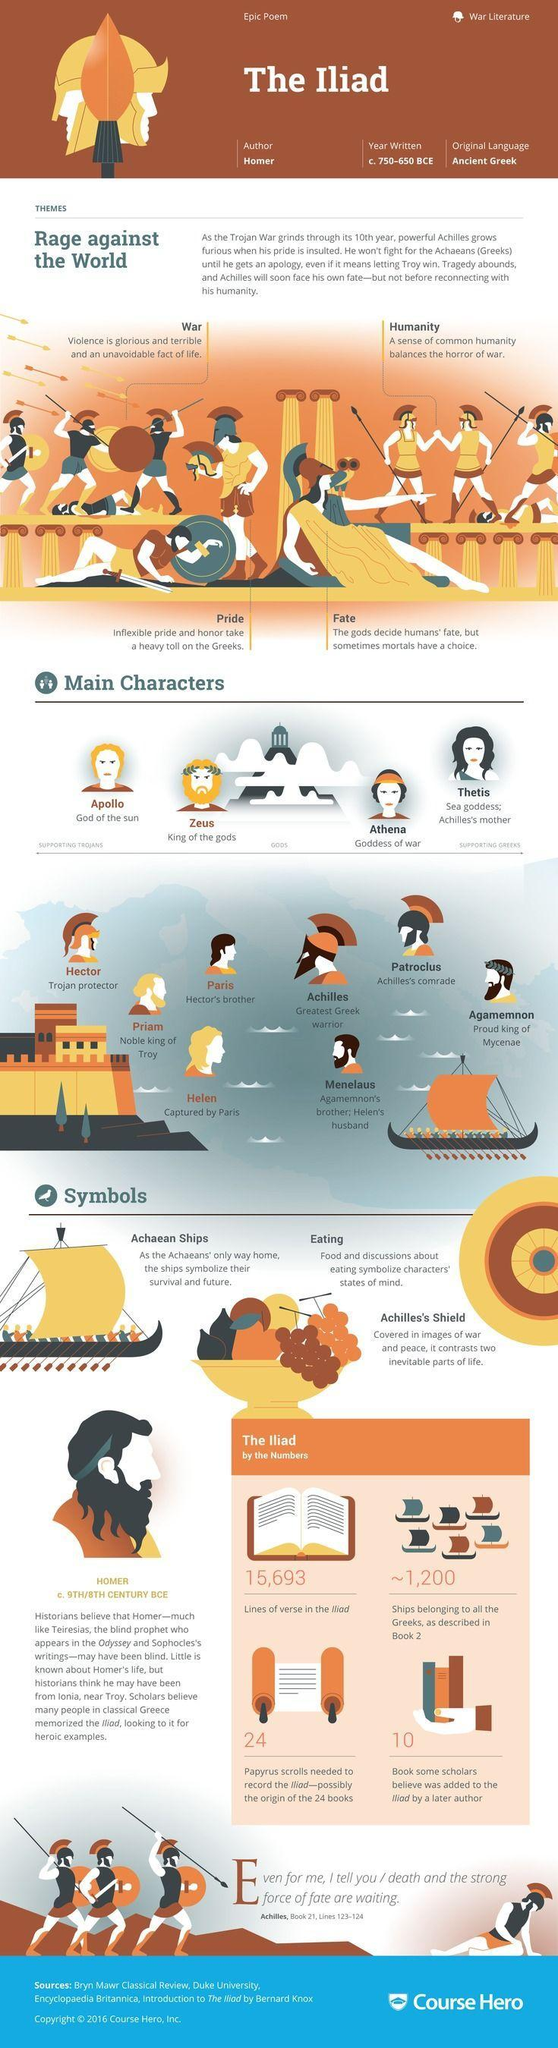Who is the King of Gods in Iliad?
Answer the question with a short phrase. Zeus How many lines of verse are in the Iliad? 15,693 Who is the king of Troy in the Iliad? Priam What is the original language of Iliad? Ancient Greek Who is the greatest Trojan warrior in the Iliad? Achilles Who wrote the Iliad? Homer 